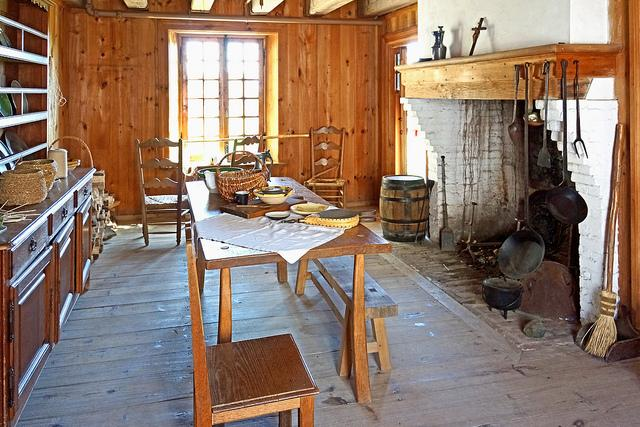What does the item hanging on the wall and closest to the broom look like? Please explain your reasoning. pitchfork. It has 2 sharp edges like a pitchfork, and it's just a bit smaller. 